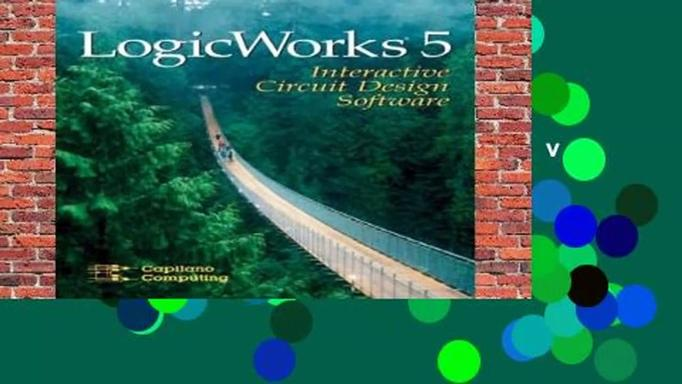What software is mentioned in the image? The software prominently featured in the image is LogicWorks 5 Interactive Circuit Design Software. This tool is uniquely developed by Capilano Computing Systems and is designed to assist users in creating and simulating digital circuits in an interactive environment. 